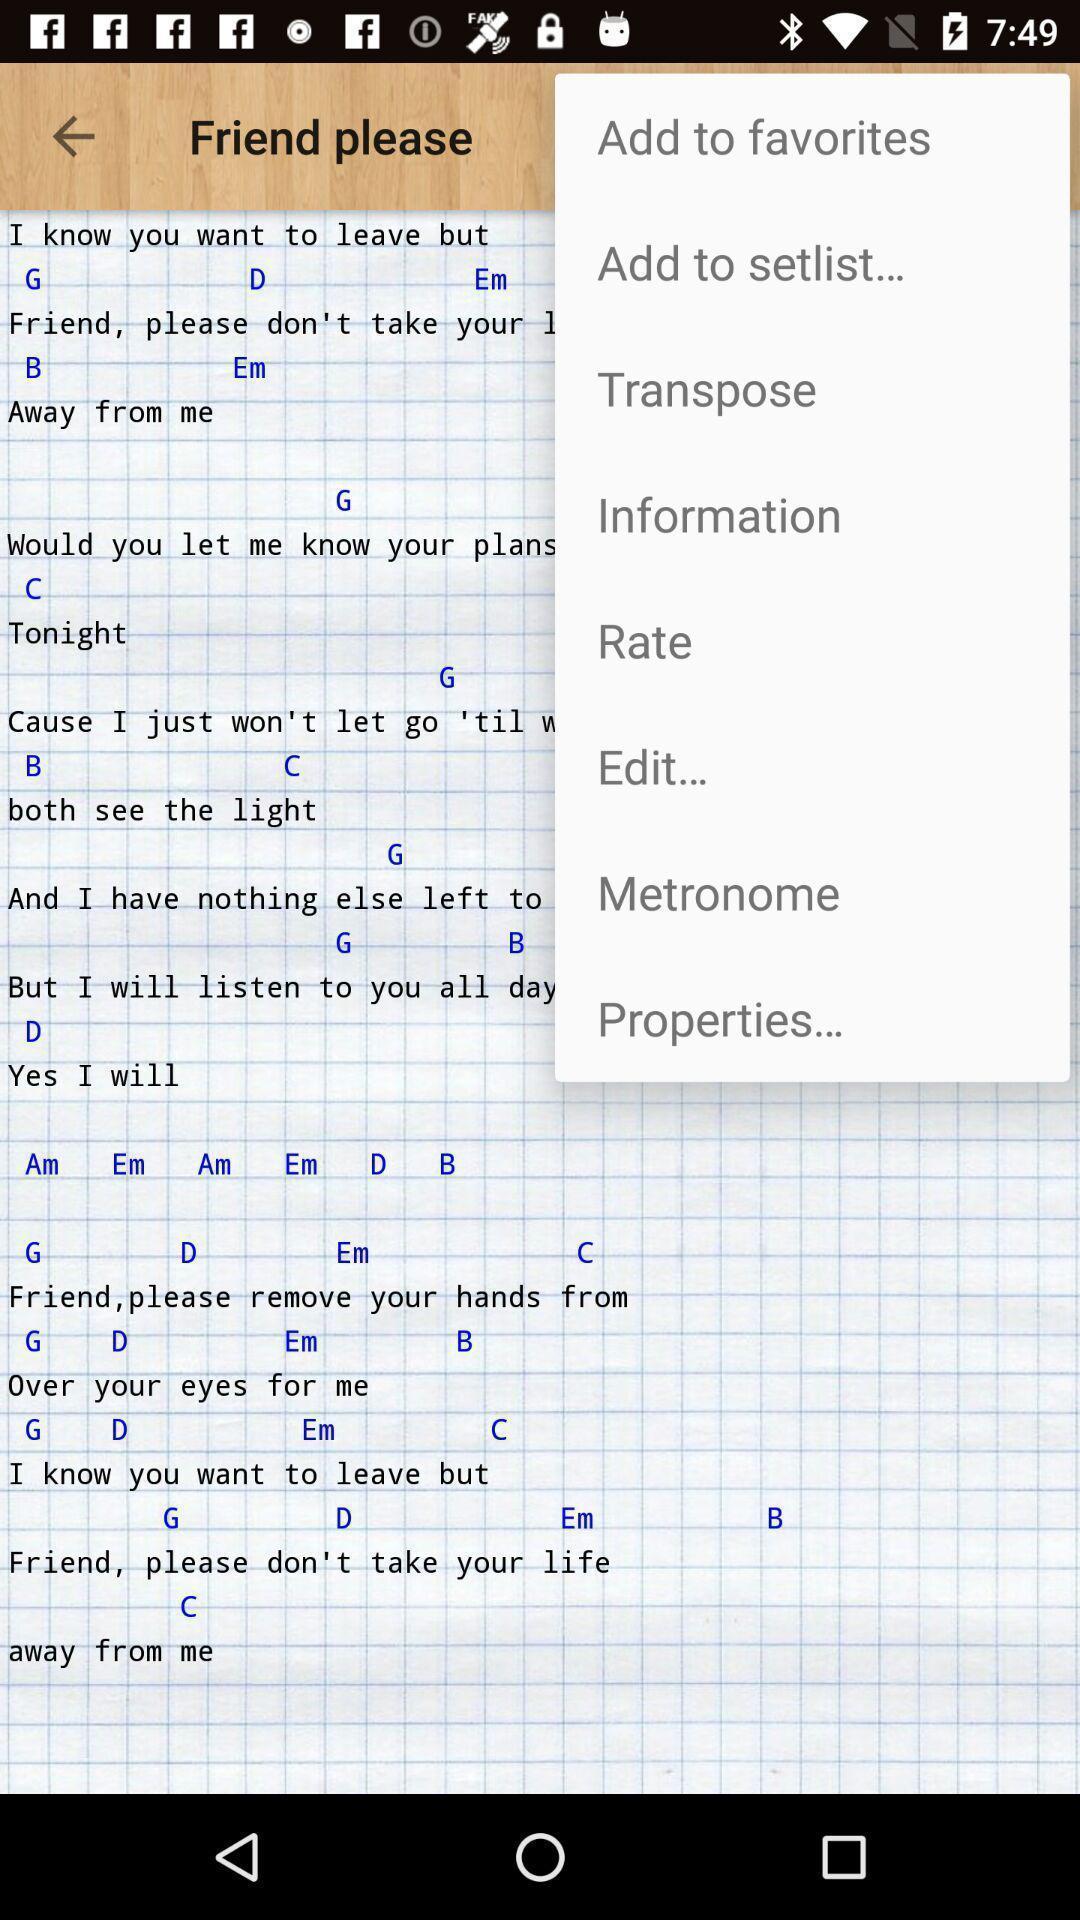What can you discern from this picture? Pop up displaying the menu options. 